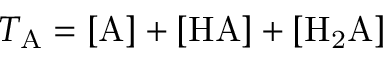Convert formula to latex. <formula><loc_0><loc_0><loc_500><loc_500>T _ { A } = [ A ] + [ H A ] + [ H _ { 2 } A ]</formula> 